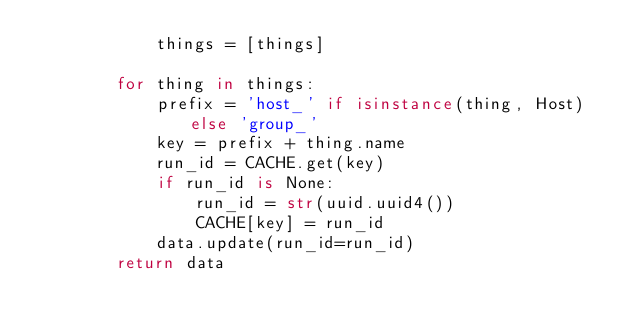<code> <loc_0><loc_0><loc_500><loc_500><_Python_>            things = [things]

        for thing in things:
            prefix = 'host_' if isinstance(thing, Host) else 'group_'
            key = prefix + thing.name
            run_id = CACHE.get(key)
            if run_id is None:
                run_id = str(uuid.uuid4())
                CACHE[key] = run_id
            data.update(run_id=run_id)
        return data
</code> 